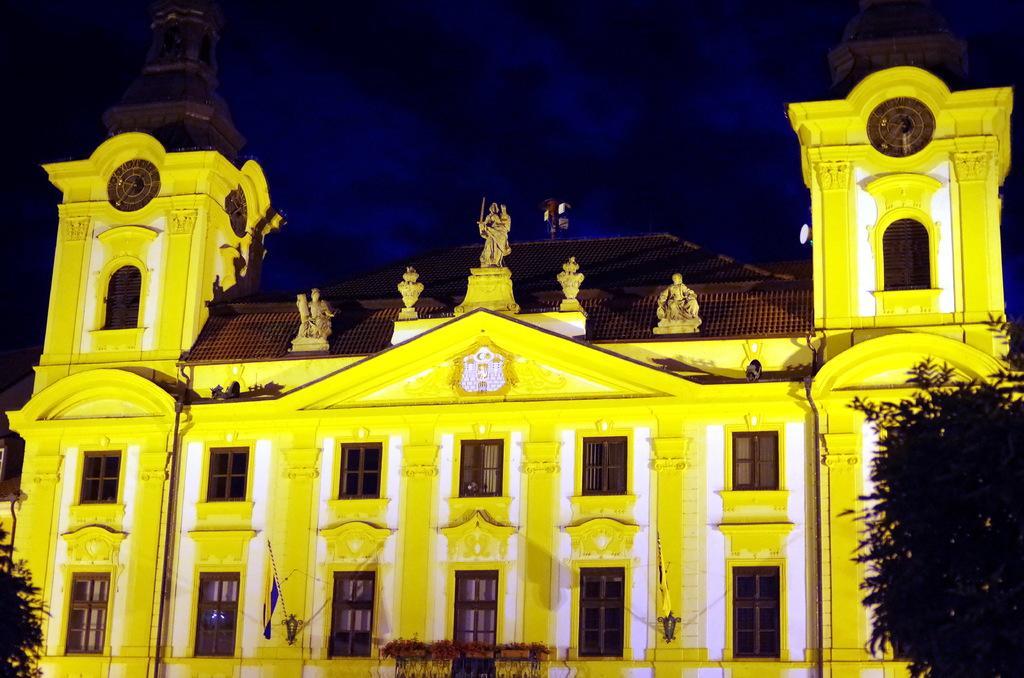Describe this image in one or two sentences. In the center of the image there is a building and flags. On the right and left side of the image we can see trees. In the background there is sky. 